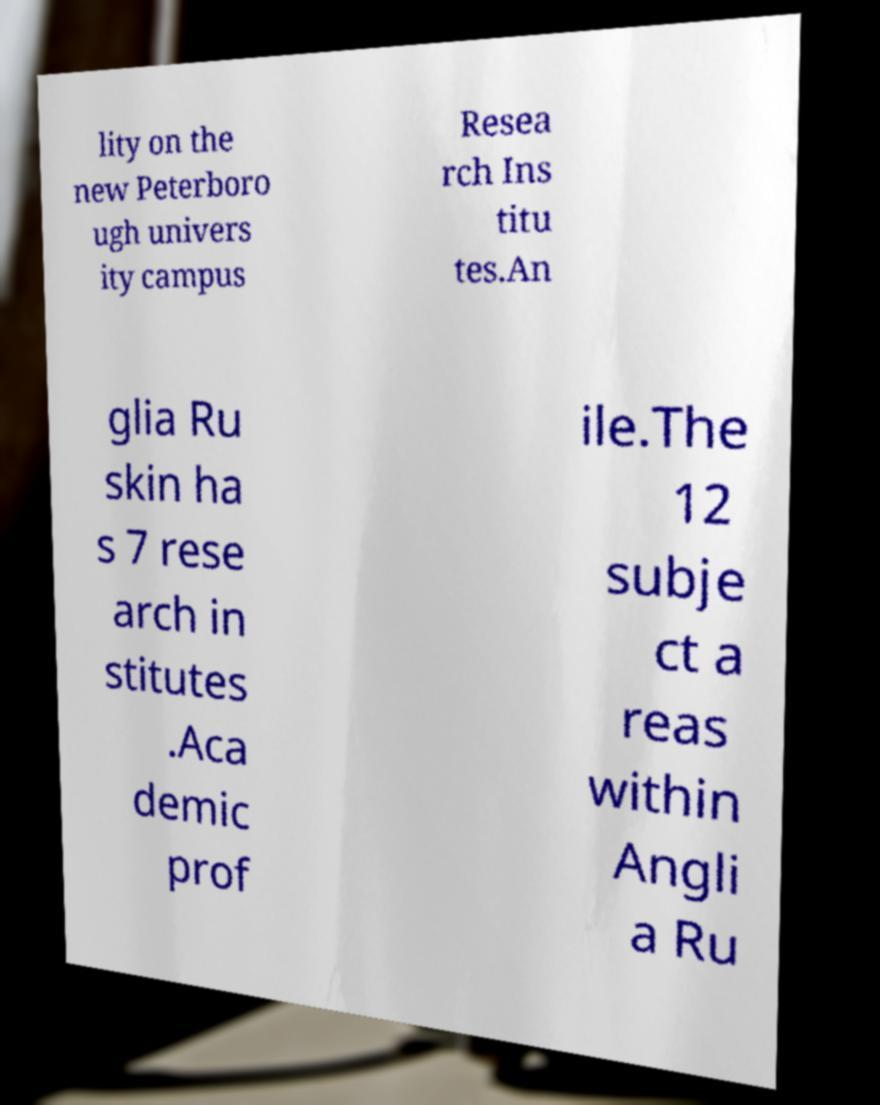Could you extract and type out the text from this image? lity on the new Peterboro ugh univers ity campus Resea rch Ins titu tes.An glia Ru skin ha s 7 rese arch in stitutes .Aca demic prof ile.The 12 subje ct a reas within Angli a Ru 